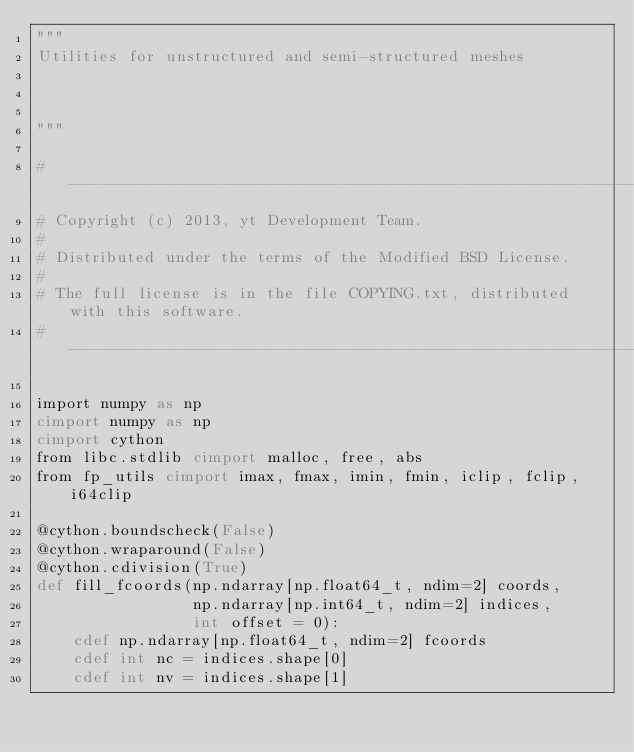<code> <loc_0><loc_0><loc_500><loc_500><_Cython_>"""
Utilities for unstructured and semi-structured meshes



"""

#-----------------------------------------------------------------------------
# Copyright (c) 2013, yt Development Team.
#
# Distributed under the terms of the Modified BSD License.
#
# The full license is in the file COPYING.txt, distributed with this software.
#-----------------------------------------------------------------------------

import numpy as np
cimport numpy as np
cimport cython
from libc.stdlib cimport malloc, free, abs
from fp_utils cimport imax, fmax, imin, fmin, iclip, fclip, i64clip

@cython.boundscheck(False)
@cython.wraparound(False)
@cython.cdivision(True)
def fill_fcoords(np.ndarray[np.float64_t, ndim=2] coords,
                 np.ndarray[np.int64_t, ndim=2] indices,
                 int offset = 0):
    cdef np.ndarray[np.float64_t, ndim=2] fcoords
    cdef int nc = indices.shape[0]
    cdef int nv = indices.shape[1]</code> 